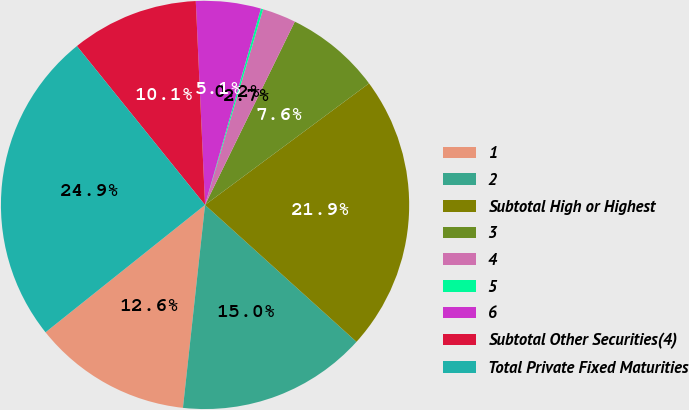Convert chart to OTSL. <chart><loc_0><loc_0><loc_500><loc_500><pie_chart><fcel>1<fcel>2<fcel>Subtotal High or Highest<fcel>3<fcel>4<fcel>5<fcel>6<fcel>Subtotal Other Securities(4)<fcel>Total Private Fixed Maturities<nl><fcel>12.55%<fcel>15.03%<fcel>21.85%<fcel>7.6%<fcel>2.66%<fcel>0.18%<fcel>5.13%<fcel>10.08%<fcel>24.92%<nl></chart> 